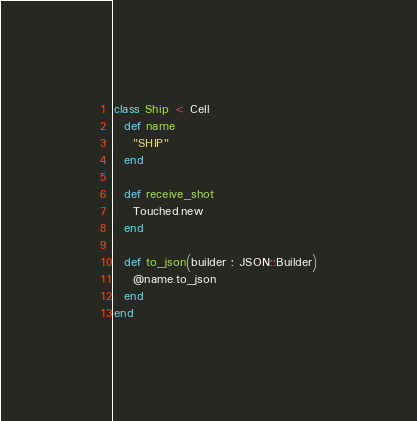<code> <loc_0><loc_0><loc_500><loc_500><_Crystal_>class Ship < Cell
  def name
    "SHIP"
  end

  def receive_shot
    Touched.new
  end

  def to_json(builder : JSON::Builder)
    @name.to_json
  end
end
</code> 